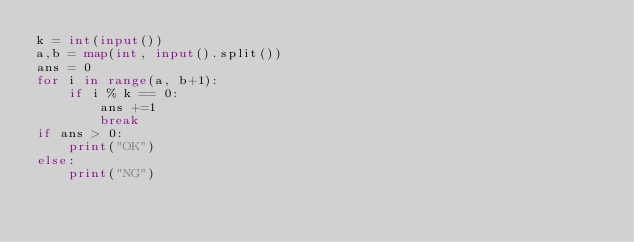Convert code to text. <code><loc_0><loc_0><loc_500><loc_500><_Python_>k = int(input())
a,b = map(int, input().split())
ans = 0
for i in range(a, b+1):
    if i % k == 0:
        ans +=1
        break
if ans > 0:
    print("OK")
else:
    print("NG")</code> 